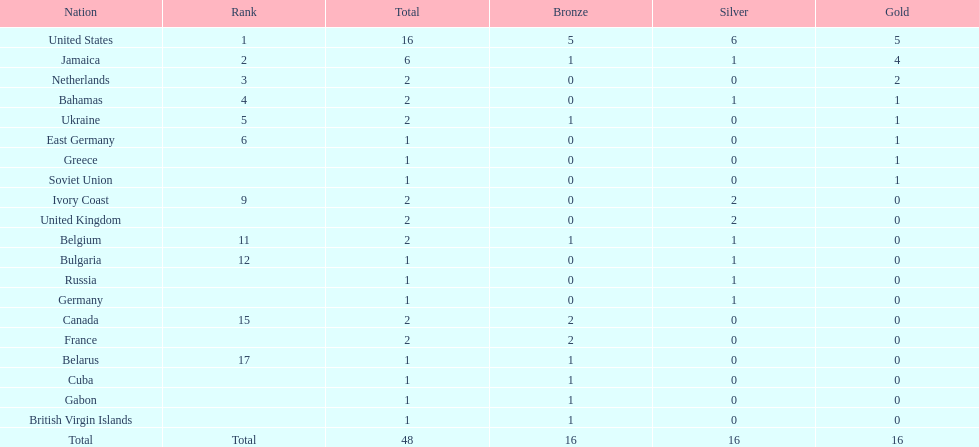Which countries won at least 3 silver medals? United States. 